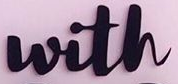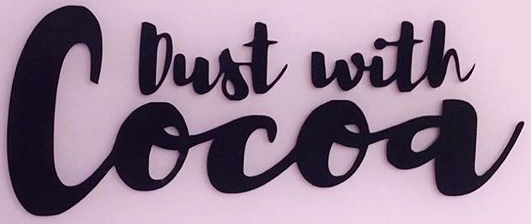Read the text from these images in sequence, separated by a semicolon. with; Cocoa 